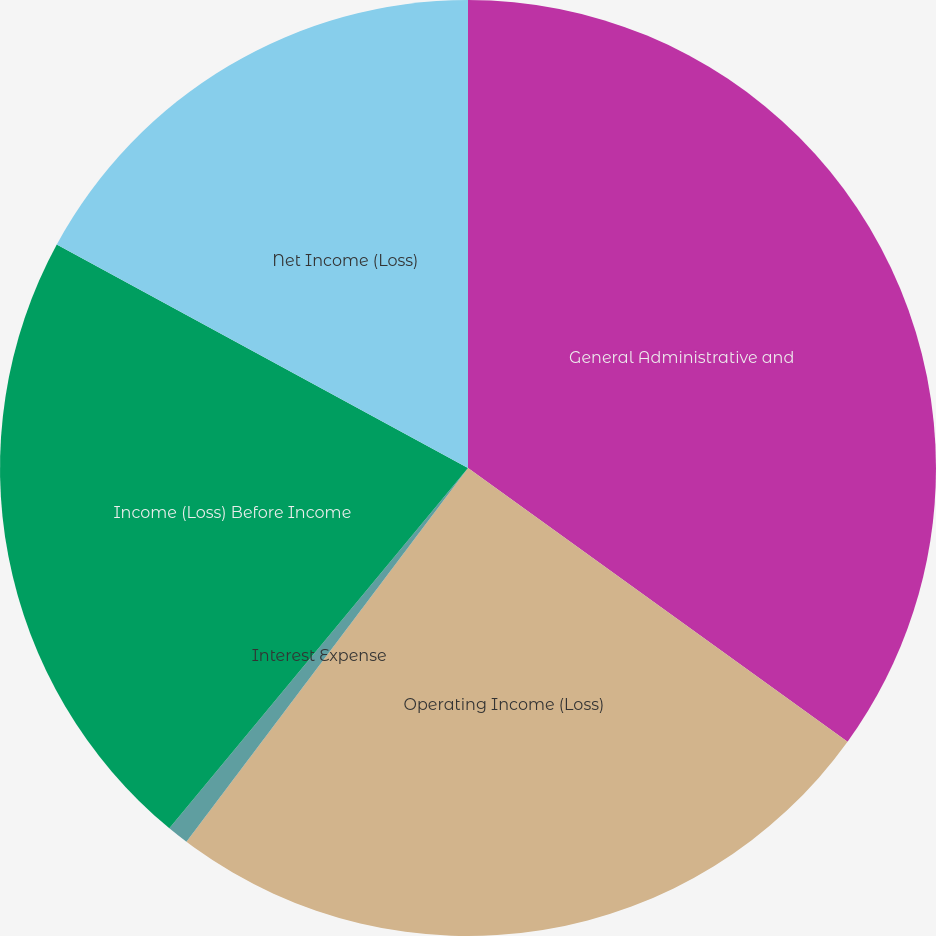Convert chart. <chart><loc_0><loc_0><loc_500><loc_500><pie_chart><fcel>General Administrative and<fcel>Operating Income (Loss)<fcel>Interest Expense<fcel>Income (Loss) Before Income<fcel>Net Income (Loss)<nl><fcel>34.95%<fcel>25.33%<fcel>0.74%<fcel>21.91%<fcel>17.08%<nl></chart> 